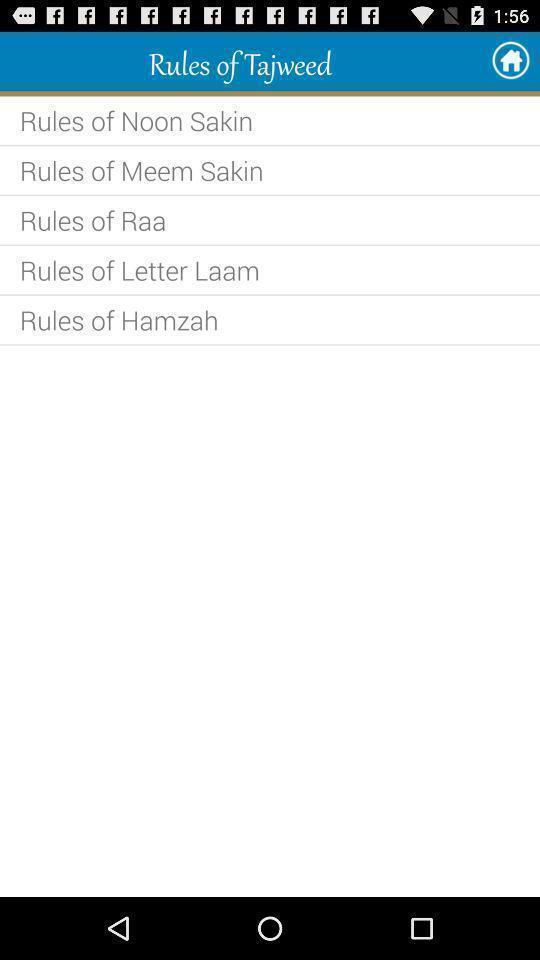What details can you identify in this image? Screen displaying the rules of a holy-book. 